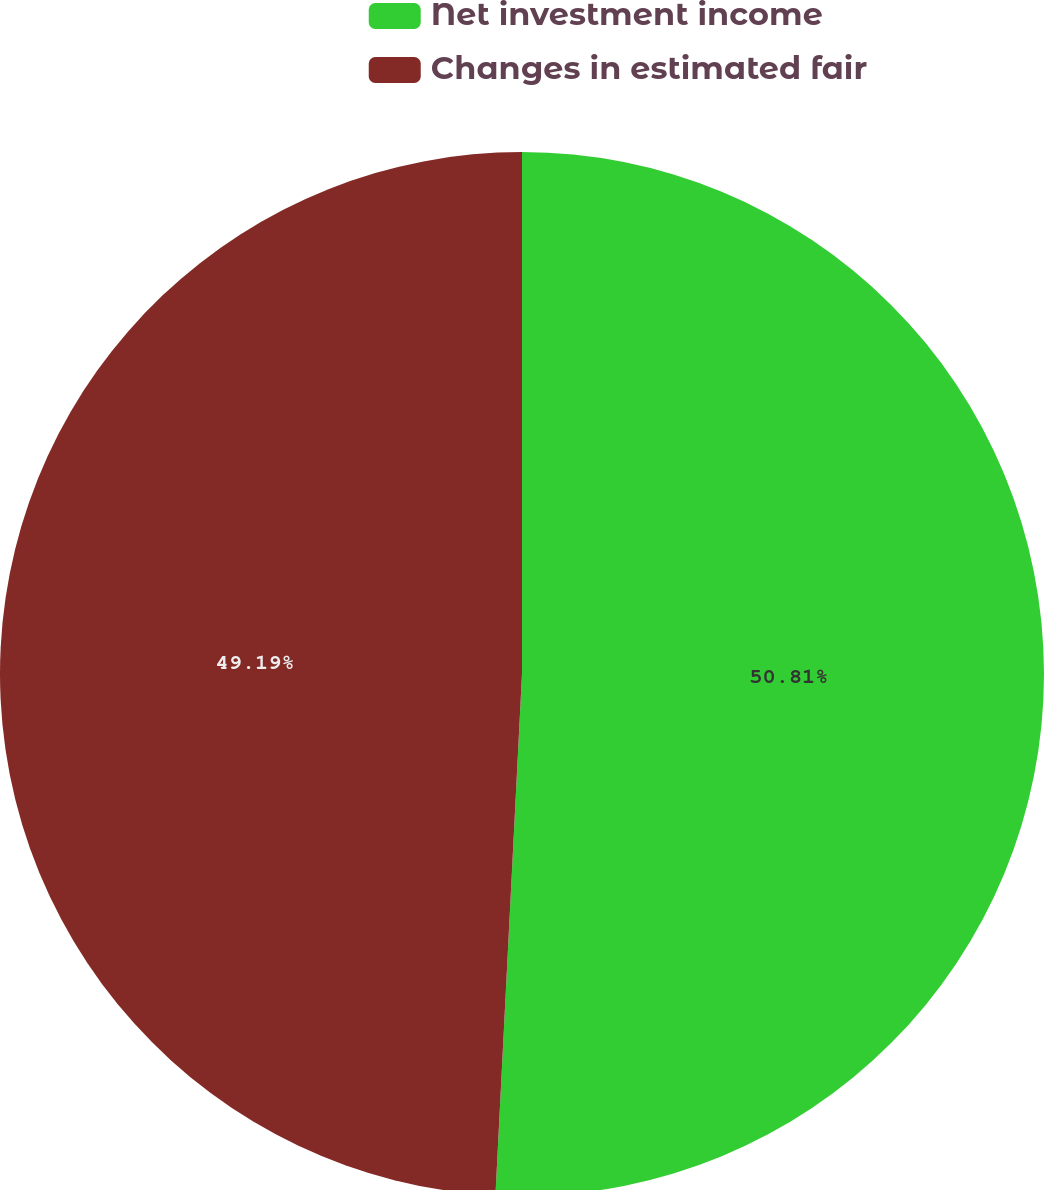Convert chart. <chart><loc_0><loc_0><loc_500><loc_500><pie_chart><fcel>Net investment income<fcel>Changes in estimated fair<nl><fcel>50.81%<fcel>49.19%<nl></chart> 